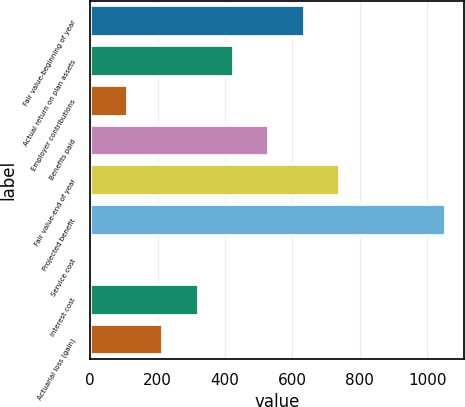<chart> <loc_0><loc_0><loc_500><loc_500><bar_chart><fcel>Fair value-beginning of year<fcel>Actual return on plan assets<fcel>Employer contributions<fcel>Benefits paid<fcel>Fair value-end of year<fcel>Projected benefit<fcel>Service cost<fcel>Interest cost<fcel>Actuarial loss (gain)<nl><fcel>636.4<fcel>426.6<fcel>111.9<fcel>531.5<fcel>741.3<fcel>1056<fcel>7<fcel>321.7<fcel>216.8<nl></chart> 